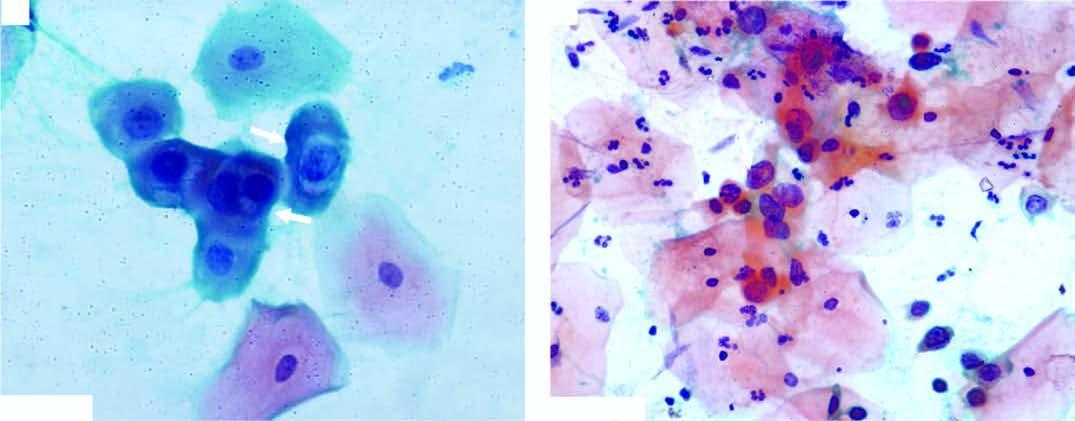what have irregular nuclear outlines?
Answer the question using a single word or phrase. Scanty cytoplasm and markedly hyperchromatic nuclei 